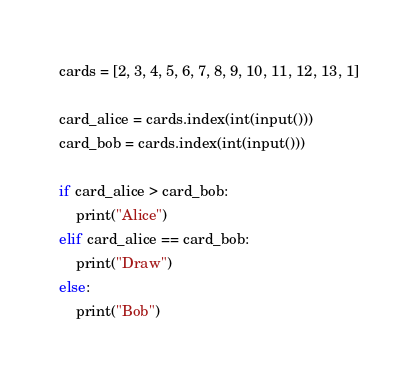<code> <loc_0><loc_0><loc_500><loc_500><_Python_>cards = [2, 3, 4, 5, 6, 7, 8, 9, 10, 11, 12, 13, 1]

card_alice = cards.index(int(input()))
card_bob = cards.index(int(input()))

if card_alice > card_bob:
    print("Alice")
elif card_alice == card_bob:
    print("Draw")
else:
    print("Bob")</code> 